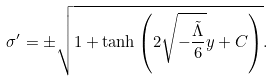Convert formula to latex. <formula><loc_0><loc_0><loc_500><loc_500>\sigma ^ { \prime } = \pm \sqrt { 1 + \tanh \left ( 2 \sqrt { - \frac { \tilde { \Lambda } } { 6 } } y + C \right ) } .</formula> 